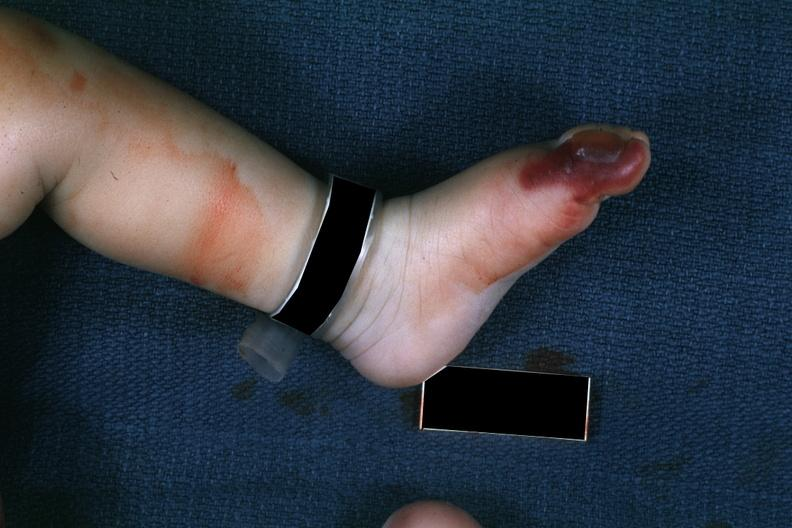does this image show 1 month old child with congenital aortic stenosis?
Answer the question using a single word or phrase. Yes 